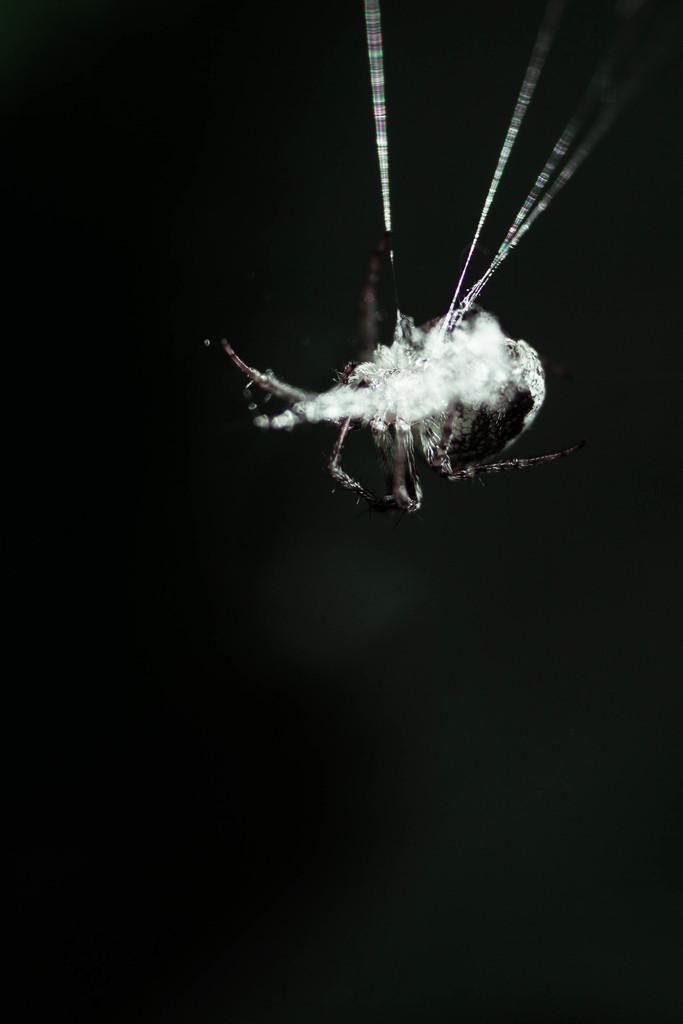In one or two sentences, can you explain what this image depicts? In the image there is an insect. And there is a black background. 